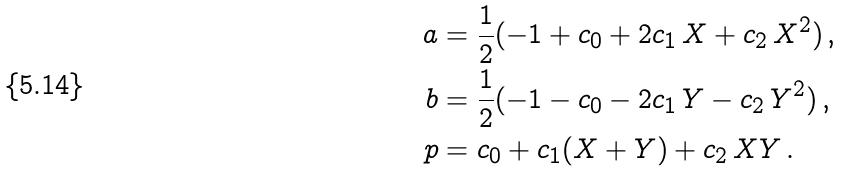<formula> <loc_0><loc_0><loc_500><loc_500>a & = { \frac { 1 } { 2 } } ( - 1 + c _ { 0 } + 2 c _ { 1 } \, X + c _ { 2 } \, X ^ { 2 } ) \, , \\ b & = { \frac { 1 } { 2 } } ( - 1 - c _ { 0 } - 2 c _ { 1 } \, Y - c _ { 2 } \, Y ^ { 2 } ) \, , \\ p & = c _ { 0 } + c _ { 1 } ( X + Y ) + c _ { 2 } \, X Y \, .</formula> 